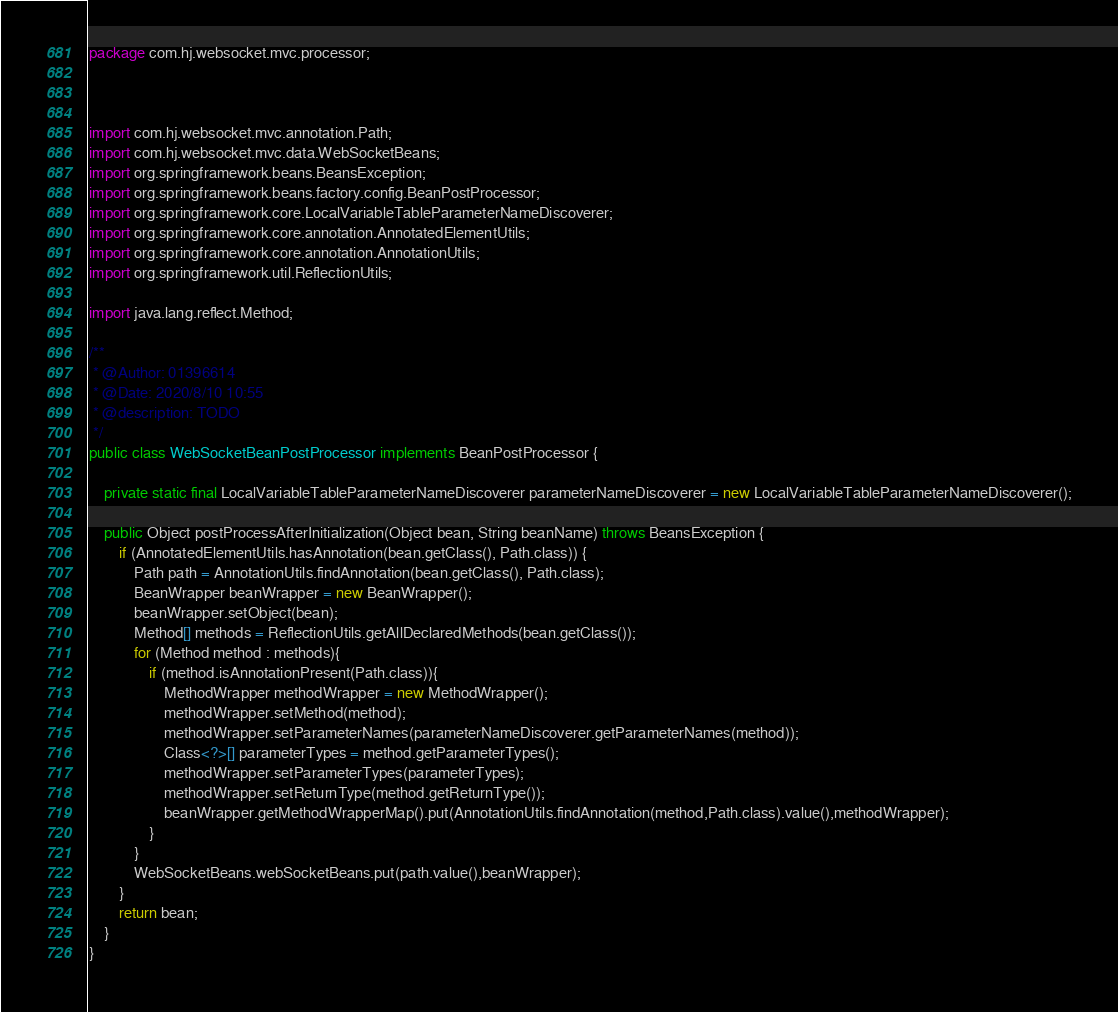Convert code to text. <code><loc_0><loc_0><loc_500><loc_500><_Java_>package com.hj.websocket.mvc.processor;



import com.hj.websocket.mvc.annotation.Path;
import com.hj.websocket.mvc.data.WebSocketBeans;
import org.springframework.beans.BeansException;
import org.springframework.beans.factory.config.BeanPostProcessor;
import org.springframework.core.LocalVariableTableParameterNameDiscoverer;
import org.springframework.core.annotation.AnnotatedElementUtils;
import org.springframework.core.annotation.AnnotationUtils;
import org.springframework.util.ReflectionUtils;

import java.lang.reflect.Method;

/**
 * @Author: 01396614
 * @Date: 2020/8/10 10:55
 * @description: TODO
 */
public class WebSocketBeanPostProcessor implements BeanPostProcessor {

    private static final LocalVariableTableParameterNameDiscoverer parameterNameDiscoverer = new LocalVariableTableParameterNameDiscoverer();

    public Object postProcessAfterInitialization(Object bean, String beanName) throws BeansException {
        if (AnnotatedElementUtils.hasAnnotation(bean.getClass(), Path.class)) {
            Path path = AnnotationUtils.findAnnotation(bean.getClass(), Path.class);
            BeanWrapper beanWrapper = new BeanWrapper();
            beanWrapper.setObject(bean);
            Method[] methods = ReflectionUtils.getAllDeclaredMethods(bean.getClass());
            for (Method method : methods){
                if (method.isAnnotationPresent(Path.class)){
                    MethodWrapper methodWrapper = new MethodWrapper();
                    methodWrapper.setMethod(method);
                    methodWrapper.setParameterNames(parameterNameDiscoverer.getParameterNames(method));
                    Class<?>[] parameterTypes = method.getParameterTypes();
                    methodWrapper.setParameterTypes(parameterTypes);
                    methodWrapper.setReturnType(method.getReturnType());
                    beanWrapper.getMethodWrapperMap().put(AnnotationUtils.findAnnotation(method,Path.class).value(),methodWrapper);
                }
            }
            WebSocketBeans.webSocketBeans.put(path.value(),beanWrapper);
        }
        return bean;
    }
}</code> 